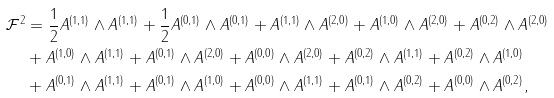Convert formula to latex. <formula><loc_0><loc_0><loc_500><loc_500>\mathcal { F } ^ { 2 } & = \frac { 1 } { 2 } A ^ { ( 1 , 1 ) } \wedge A ^ { ( 1 , 1 ) } + \frac { 1 } { 2 } A ^ { ( 0 , 1 ) } \wedge A ^ { ( 0 , 1 ) } + A ^ { ( 1 , 1 ) } \wedge A ^ { ( 2 , 0 ) } + A ^ { ( 1 , 0 ) } \wedge A ^ { ( 2 , 0 ) } + A ^ { ( 0 , 2 ) } \wedge A ^ { ( 2 , 0 ) } \\ & + A ^ { ( 1 , 0 ) } \wedge A ^ { ( 1 , 1 ) } + A ^ { ( 0 , 1 ) } \wedge A ^ { ( 2 , 0 ) } + A ^ { ( 0 , 0 ) } \wedge A ^ { ( 2 , 0 ) } + A ^ { ( 0 , 2 ) } \wedge A ^ { ( 1 , 1 ) } + A ^ { ( 0 , 2 ) } \wedge A ^ { ( 1 , 0 ) } \\ & + A ^ { ( 0 , 1 ) } \wedge A ^ { ( 1 , 1 ) } + A ^ { ( 0 , 1 ) } \wedge A ^ { ( 1 , 0 ) } + A ^ { ( 0 , 0 ) } \wedge A ^ { ( 1 , 1 ) } + A ^ { ( 0 , 1 ) } \wedge A ^ { ( 0 , 2 ) } + A ^ { ( 0 , 0 ) } \wedge A ^ { ( 0 , 2 ) } ,</formula> 